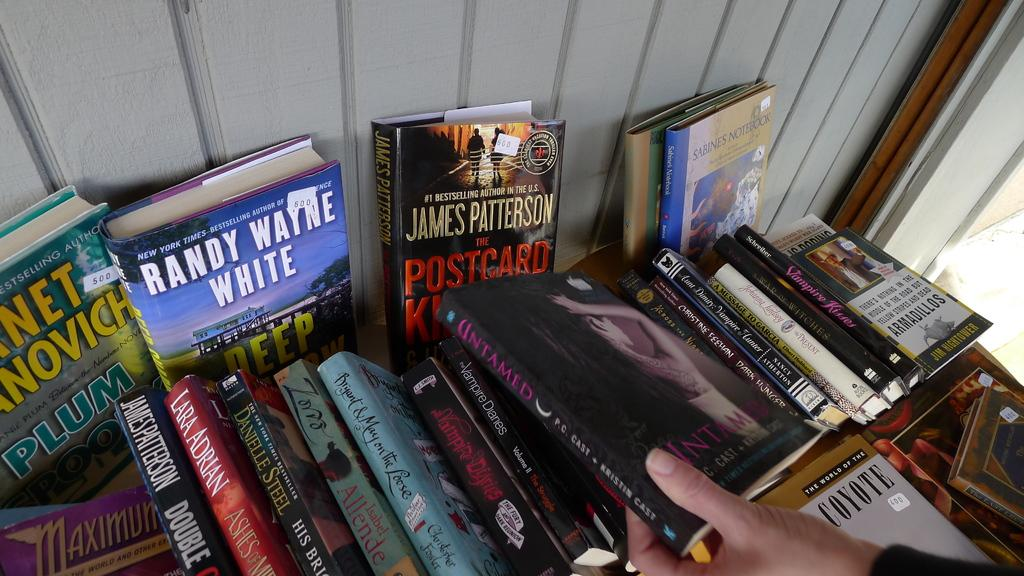What objects can be seen in the image? There are books in the image. What body part is visible in the image? A human hand is present in the image. What type of material is visible in the background of the image? There is a wooden wall in the background of the image. What type of force is being applied by the police in the image? There is no police presence or force being applied in the image; it only features books and a human hand. 